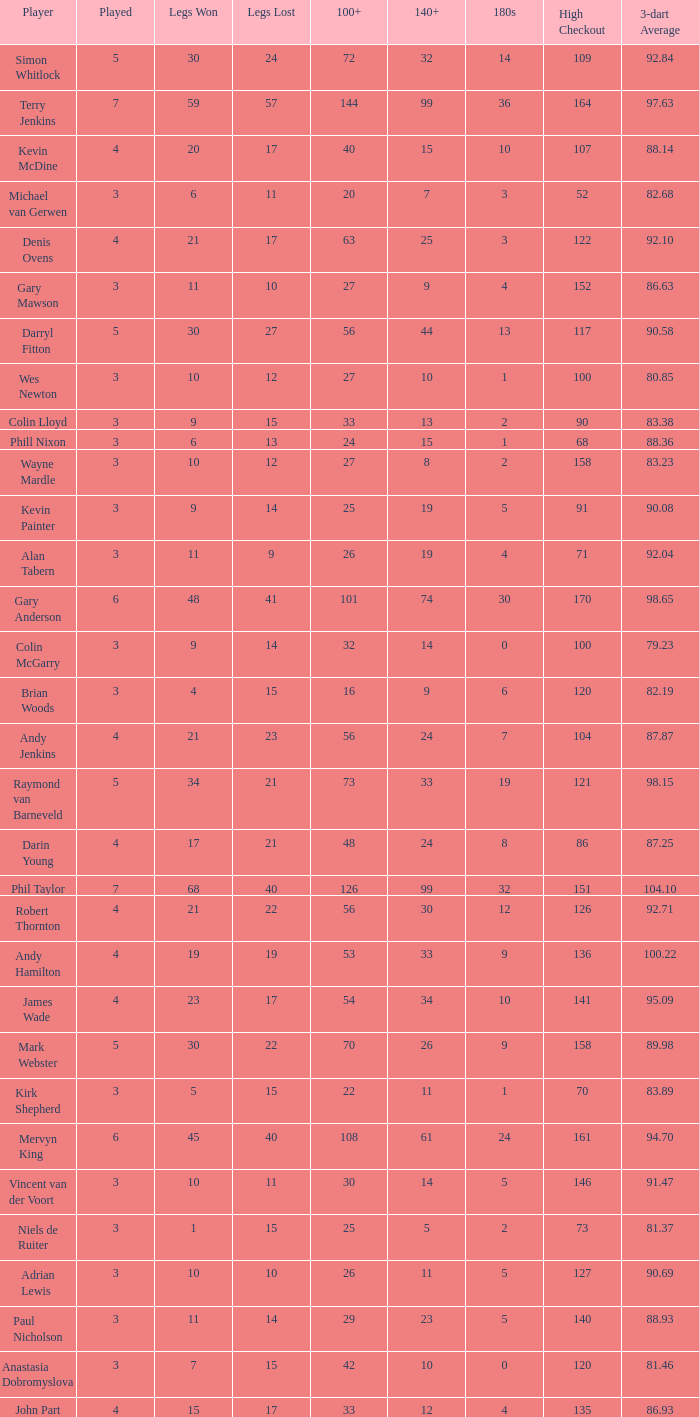What is the played number when the high checkout is 135? 4.0. 